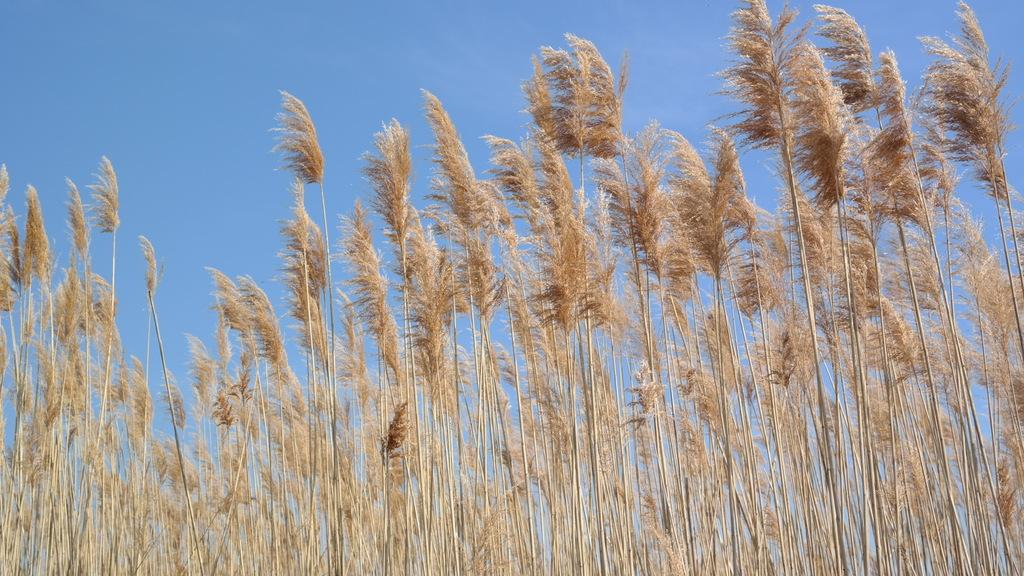What is the main subject of the image? The main subject of the image is many plants. What can be seen in the background of the image? The sky is clear in the image. What type of sugar is being used to sweeten the class in the image? There is no class or sugar present in the image; it features many plants and a clear sky. How many bananas can be seen hanging from the plants in the image? There are no bananas present in the image; it only features plants and a clear sky. 